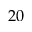<formula> <loc_0><loc_0><loc_500><loc_500>2 0</formula> 